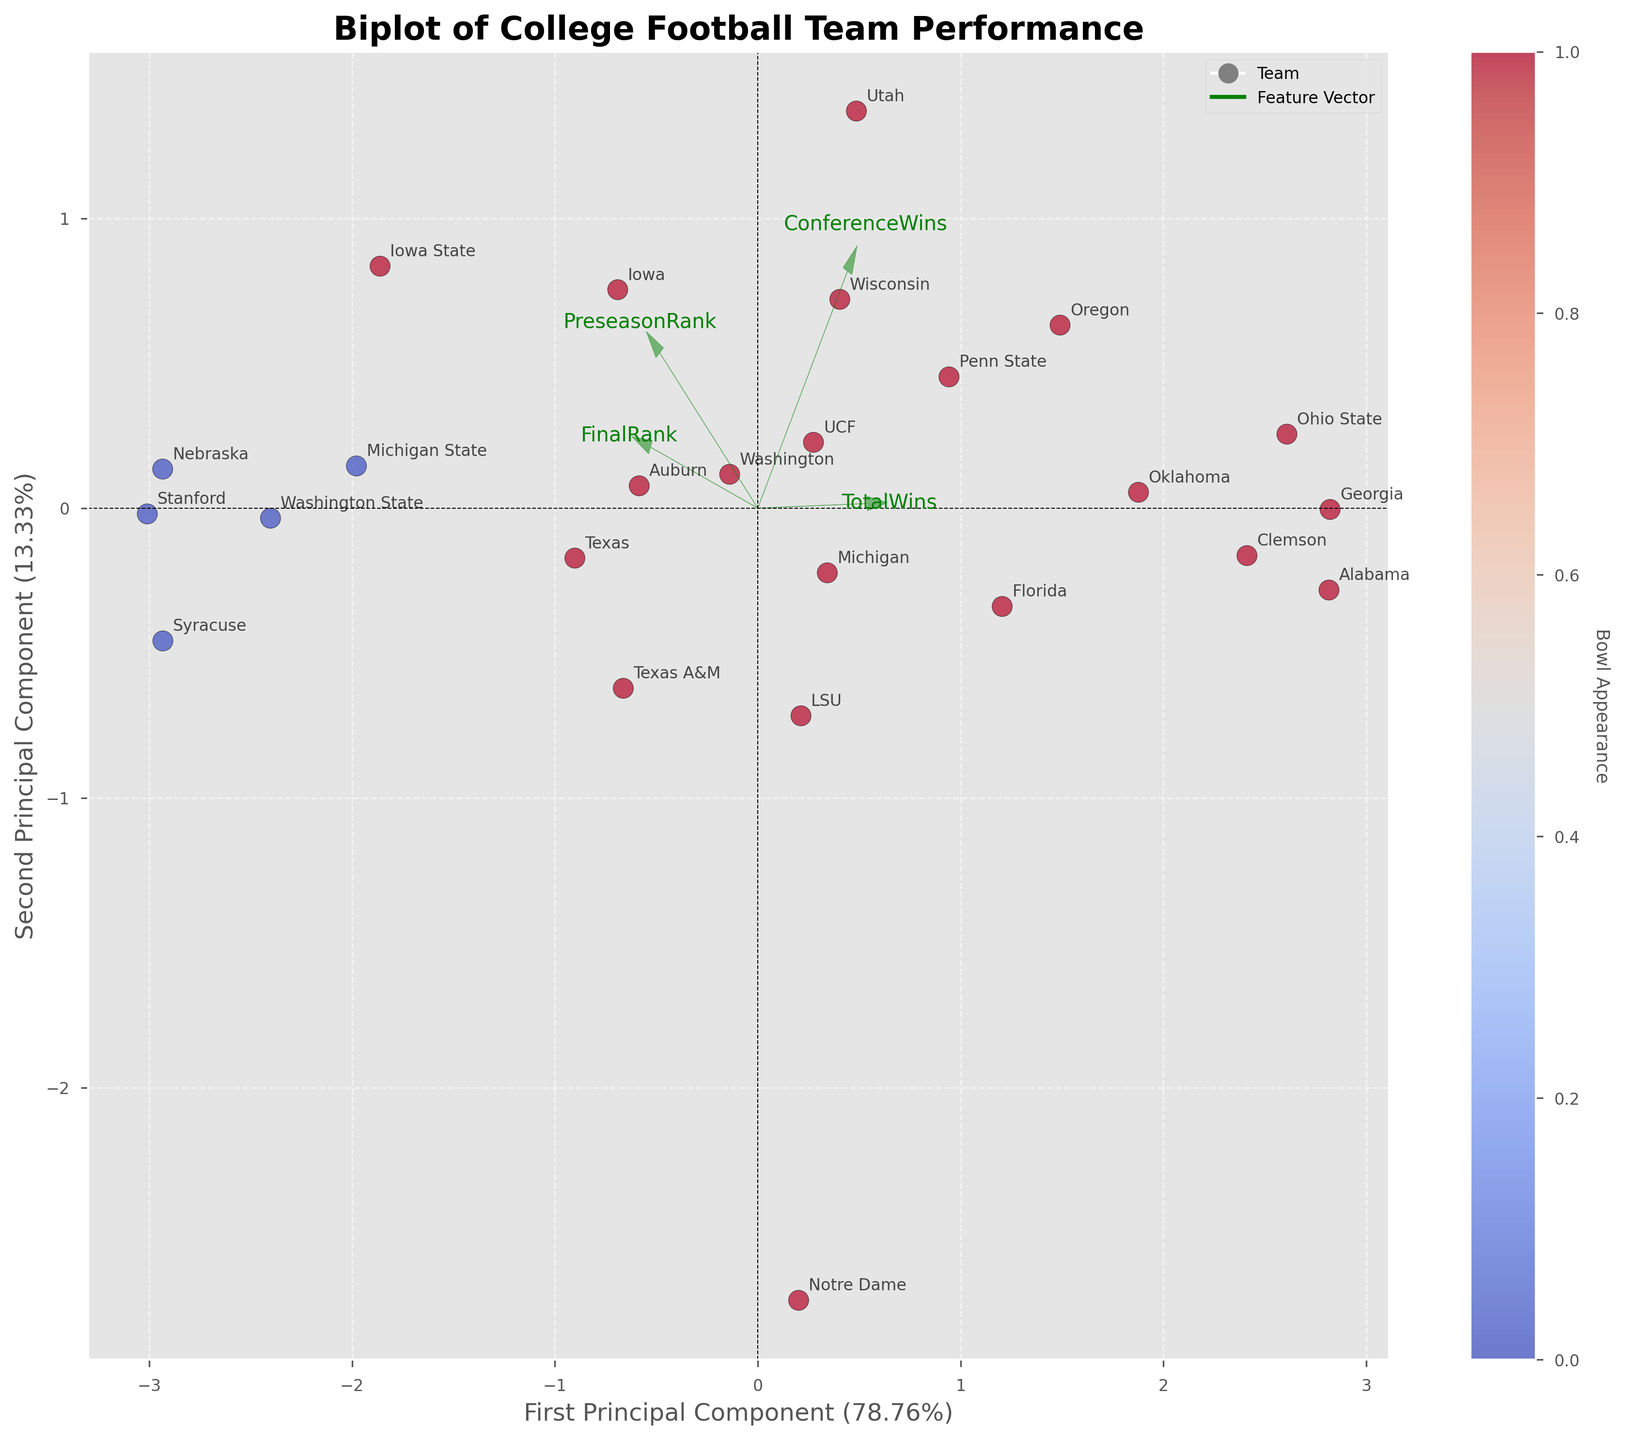Which team has the highest PreseasonRank? By visually observing the scatter plot, the position of points is indicative of their ranks. The highest PreseasonRank corresponds to the point farthest in the direction of the arrow representing PreseasonRank. From the plot, the team with the highest PreseasonRank of 1 is Alabama, so we confirm this by the biplot's annotations and their placement near the origin on the PreseasonRank axis.
Answer: Alabama Which team has the widest discrepancy between PreseasonRank and FinalRank? To identify the team with the biggest difference between PreseasonRank and FinalRank, observe the distances in opposite directions along the PreseasonRank and FinalRank vectors. Texas, starting at PreseasonRank 10 and ending at FinalRank 25, visibly has a wide disparity in positioning on the biplot.
Answer: Texas What's the sum of the PreseasonRank and FinalRank for Ohio State? Check Ohio State's PreseasonRank and FinalRank coordinates on the plot. Ohio State has a PreseasonRank of 3 and a FinalRank of 3. Summing these values gives 3 + 3 = 6.
Answer: 6 Which feature vector shows the most variation on the biplot? The most variation is observed by the feature whose vector is longest. Checking the drawn vectors, the PreseasonRank and FinalRank vectors look to be similarly long and likely show the highest variation, but confirm by assessing the plot if one is demonstrably longer.
Answer: PreseasonRank / FinalRank How many teams had a bowl appearance? The color bar indicates bowl appearances, and data points colored according to this key count the total teams. Count all the points colored similarly (either all points are the same color). By verifying the scatter comparison, it shows that there are 19 teams marked with color indicating a bowl appearance.
Answer: 19 Compare Alabama and Georgia in terms of their positions in PC space. Who performed better? By comparing positions, we examine how Alabama and Georgia are mapped relative to the FinalRank vector's direction. Georgia, plotted nearer to the higher-final-rank side of the vector and thus closer to favorable outcomes, registered better performance.
Answer: Georgia What is the principal component explaining the least variance? By examining the plot labels, the percentage of variance explained by each principal component (PC) is detailed. The component with the smaller percentage is the one explaining the least variance.
Answer: Second Principal Component Which team improved the most based on their PreseasonRank to FinalRank change? Identify from the plot shift directionality along the vectors: the team starting far at PreseasonRank but ending near the optimum spot at FinalRank. Georgia, starting at PreseasonRank 5 and moving to FinalRank 1, demonstrates this improvement.
Answer: Georgia Which team is closest to the center in PCA space? Observe the scatter plot for the team whose coordinates reside nearest to the origin of the PCA plot. Notre Dame appears to sit closest to the center.
Answer: Notre Dame What percentage of the total variance is explained by the first principal component? Refer to the x-axis label indicating the percentage, which shows the explained variance attributed to the first principal component. The label often reads "First Principal Component (XX%)" in bivisuals.
Answer: (Value from plot)% 